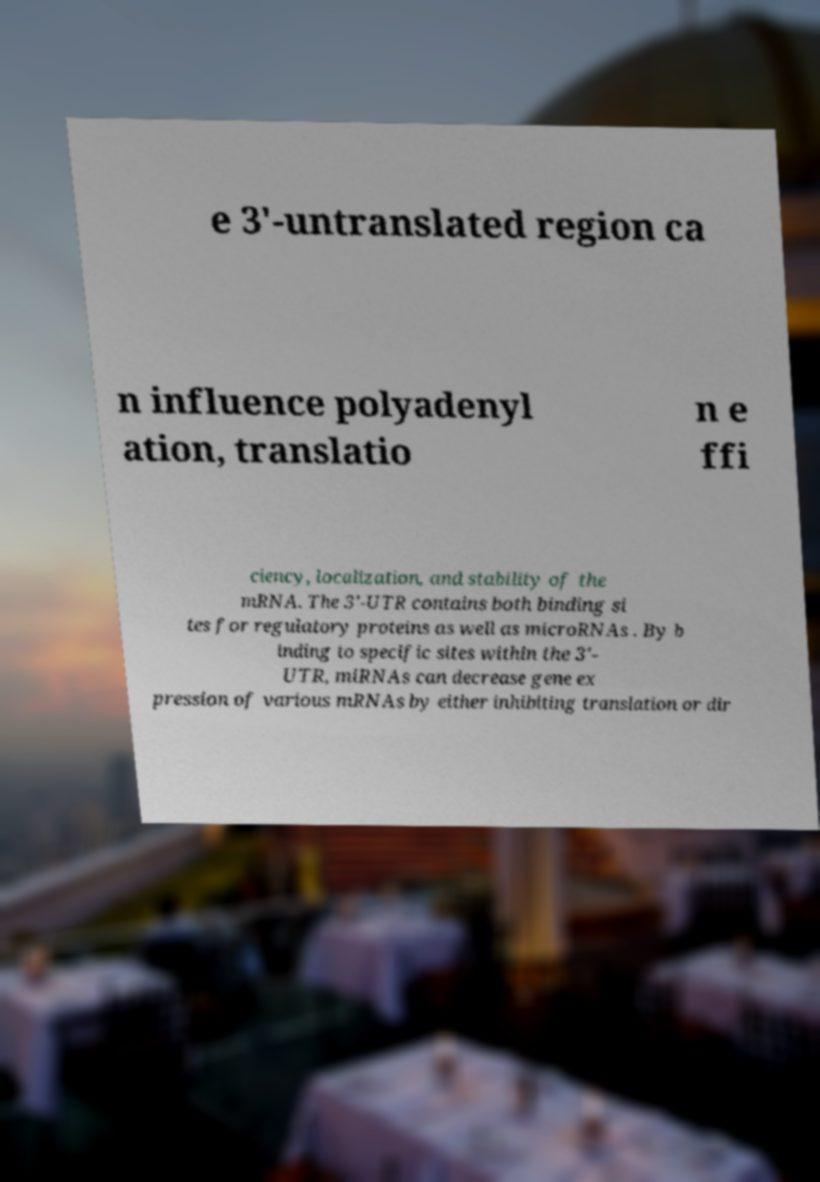Please read and relay the text visible in this image. What does it say? e 3′-untranslated region ca n influence polyadenyl ation, translatio n e ffi ciency, localization, and stability of the mRNA. The 3′-UTR contains both binding si tes for regulatory proteins as well as microRNAs . By b inding to specific sites within the 3′- UTR, miRNAs can decrease gene ex pression of various mRNAs by either inhibiting translation or dir 